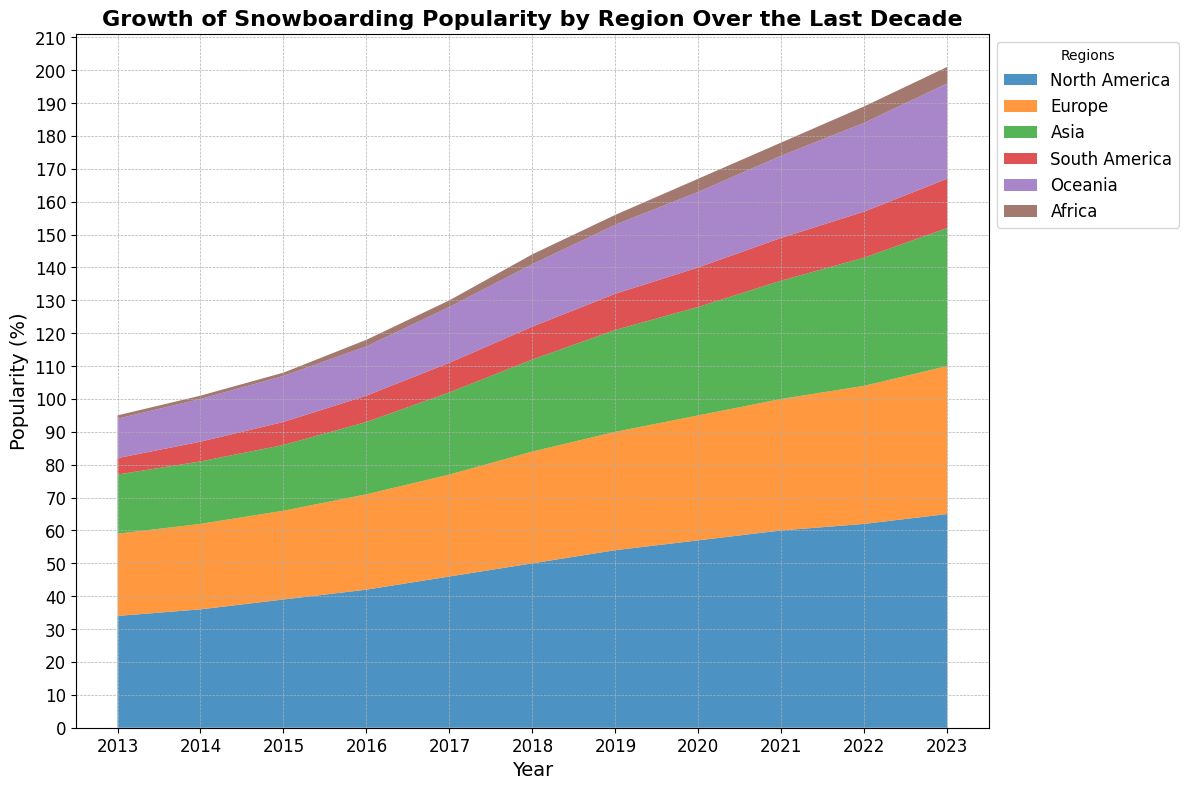Which region has shown the fastest growth in snowboarding popularity? To determine the fastest growth, we need to compare the increase in popularity across regions over time. North America shows a growth from about 34% to 65%, which is the largest increase among the regions.
Answer: North America Which two regions had the closest popularity percentages in 2013? Referring to the 2013 data, Europe and Asia had very close popularity rates: Europe at 25% and Asia at 18%.
Answer: Europe and Asia By how much did North America's popularity increase from 2013 to 2023? North America's popularity in 2013 was 34% and 65% in 2023. The increase is 65% - 34% = 31%.
Answer: 31% Which region had the smallest popularity percentage in 2023? In 2023, Africa had the smallest popularity percentage at 5%.
Answer: Africa How does the growth trend in Oceania compare to that in South America? From 2013 to 2023, Oceania's popularity increased from 12% to 29%, while South America's increased from 5% to 15%. Oceania's growth was 17% whereas South America's was 10%. Thus, Oceania showed a larger increase compared to South America.
Answer: Oceania showed a larger increase What is the combined popularity percentage of Asia and Europe in 2021? In 2021, Asia had a popularity of 36% and Europe had 40%. Their combined percentage is 36% + 40% = 76%.
Answer: 76% In which years did Asia's popularity exceed 30%? From the data, Asia's popularity exceeded 30% from 2019 onward (31% in 2019, 33% in 2020, 36% in 2021, 39% in 2022, and 42% in 2023).
Answer: 2019, 2020, 2021, 2022, 2023 What visual trend can you observe about the growth of Africa's snowboarding popularity over the decade? Observing the area plot, Africa's popularity gradually increased, showing a steady and modest upward trend from 1% in 2013 to 5% in 2023.
Answer: Steady and modest upward trend Which year showed the highest overall growth across all regions combined? By examining the plot, the overall area (representing combined growth) seems to expand the most between 2017 and 2018, which indicates significant growth during this period.
Answer: 2017-2018 What can you infer about the popularity trends of snowboarding in Europe and North America during the last five years? The last five years show a consistent upward trend in both Europe and North America, with North America maintaining higher values but both exhibiting steady growth.
Answer: Steady upward trend in both regions 